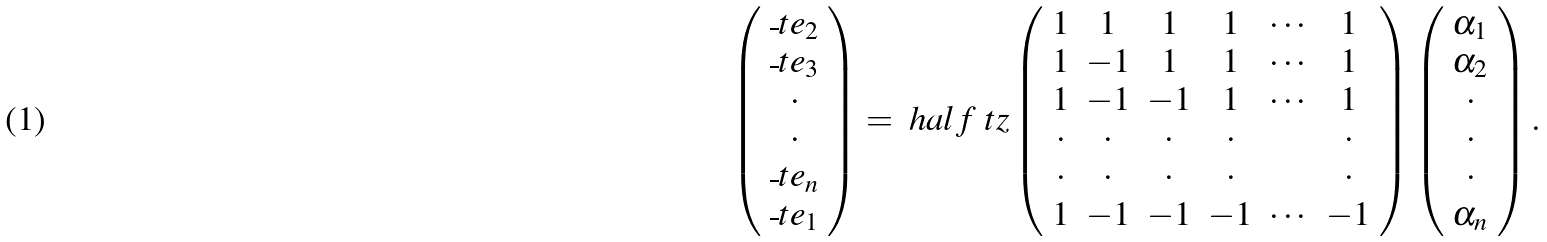Convert formula to latex. <formula><loc_0><loc_0><loc_500><loc_500>\left ( \begin{array} { c } \overline { \ } t e _ { 2 } \\ \overline { \ } t e _ { 3 } \\ \cdot \\ \cdot \\ \overline { \ } t e _ { n } \\ \overline { \ } t e _ { 1 } \end{array} \right ) = \ h a l f \ t z \left ( \begin{array} { c c c c c c } 1 & 1 & 1 & 1 & \cdots & 1 \\ 1 & - 1 & 1 & 1 & \cdots & 1 \\ 1 & - 1 & - 1 & 1 & \cdots & 1 \\ \cdot & \cdot & \cdot & \cdot & & \cdot \\ \cdot & \cdot & \cdot & \cdot & & \cdot \\ 1 & - 1 & - 1 & - 1 & \cdots & - 1 \end{array} \right ) \left ( \begin{array} { c } \alpha _ { 1 } \\ \alpha _ { 2 } \\ \cdot \\ \cdot \\ \cdot \\ \alpha _ { n } \end{array} \right ) .</formula> 